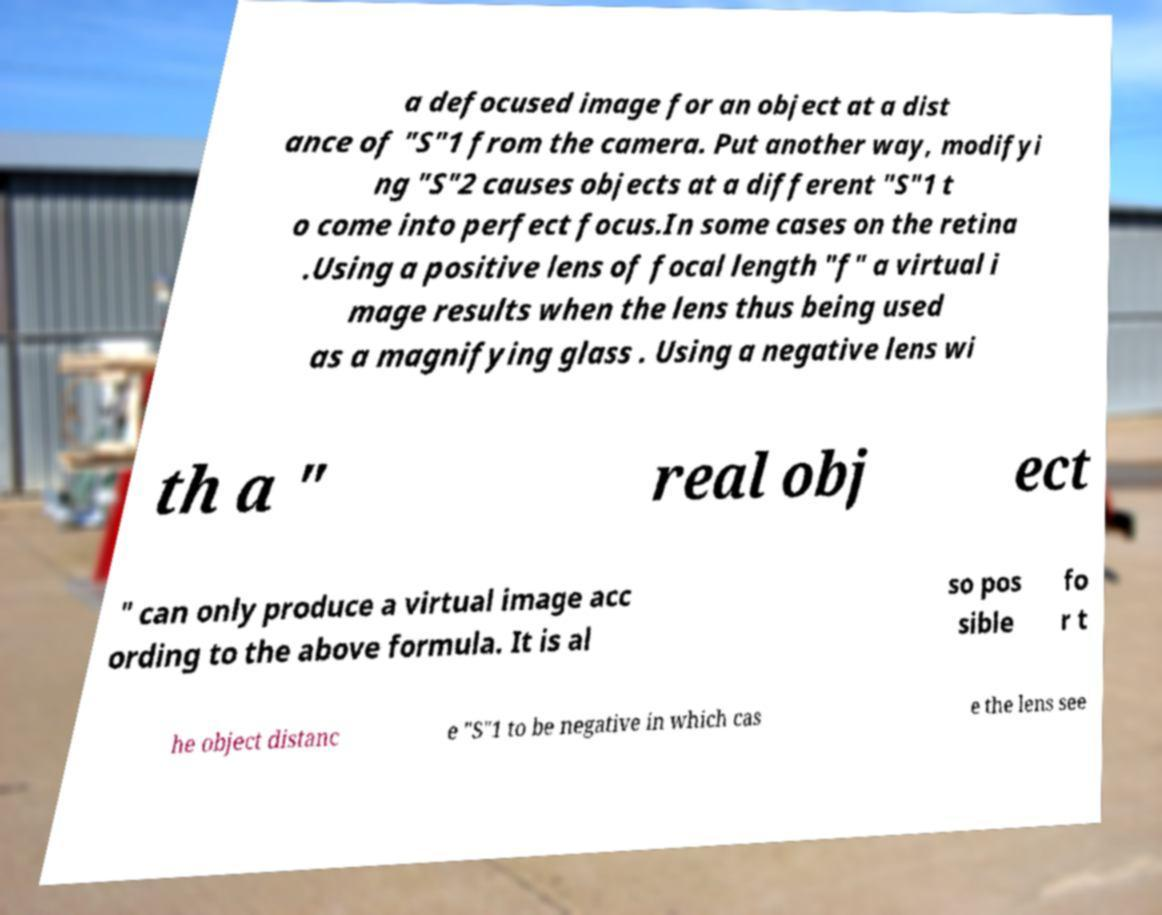Please identify and transcribe the text found in this image. a defocused image for an object at a dist ance of "S"1 from the camera. Put another way, modifyi ng "S"2 causes objects at a different "S"1 t o come into perfect focus.In some cases on the retina .Using a positive lens of focal length "f" a virtual i mage results when the lens thus being used as a magnifying glass . Using a negative lens wi th a " real obj ect " can only produce a virtual image acc ording to the above formula. It is al so pos sible fo r t he object distanc e "S"1 to be negative in which cas e the lens see 